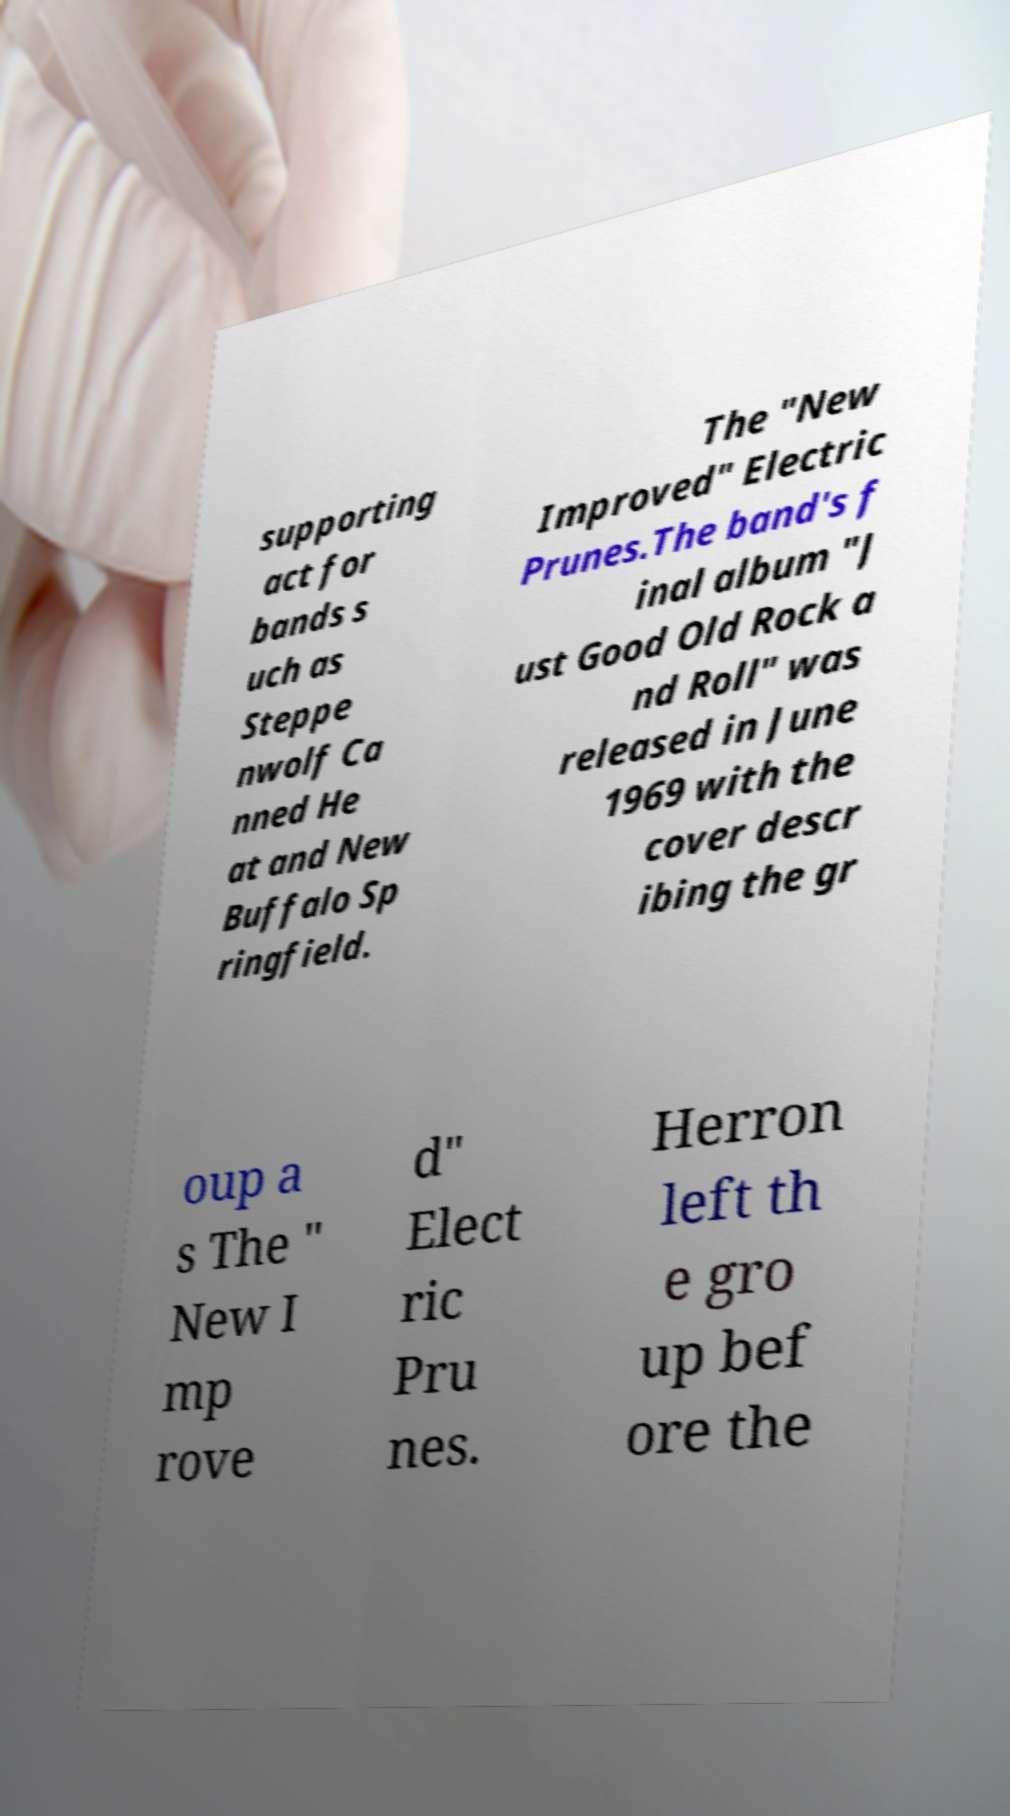Please read and relay the text visible in this image. What does it say? supporting act for bands s uch as Steppe nwolf Ca nned He at and New Buffalo Sp ringfield. The "New Improved" Electric Prunes.The band's f inal album "J ust Good Old Rock a nd Roll" was released in June 1969 with the cover descr ibing the gr oup a s The " New I mp rove d" Elect ric Pru nes. Herron left th e gro up bef ore the 